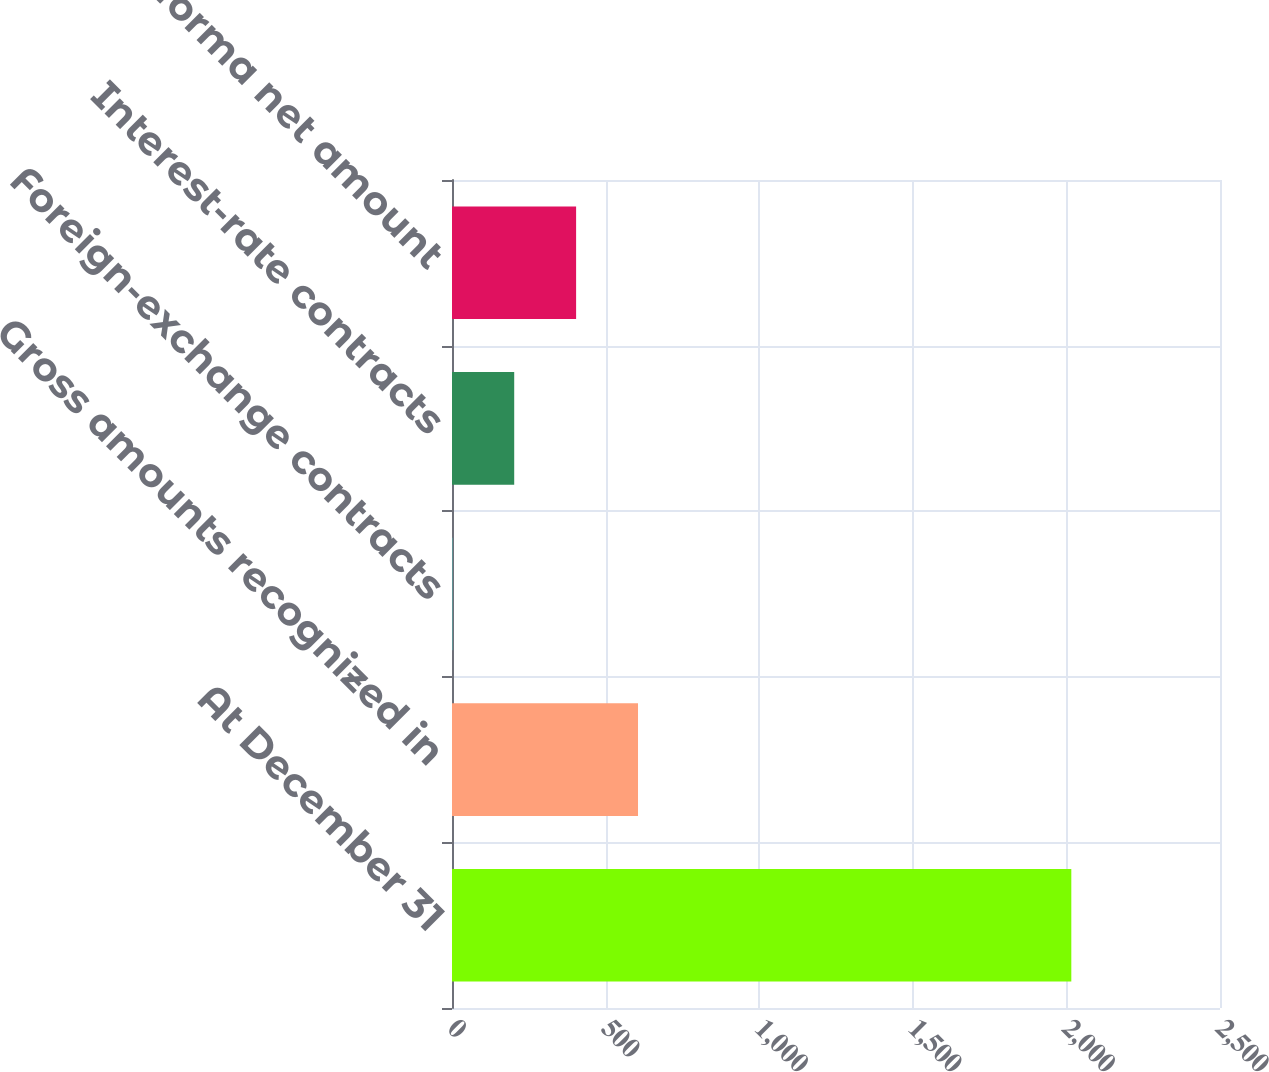Convert chart to OTSL. <chart><loc_0><loc_0><loc_500><loc_500><bar_chart><fcel>At December 31<fcel>Gross amounts recognized in<fcel>Foreign-exchange contracts<fcel>Interest-rate contracts<fcel>Pro forma net amount<nl><fcel>2016<fcel>605.5<fcel>1<fcel>202.5<fcel>404<nl></chart> 